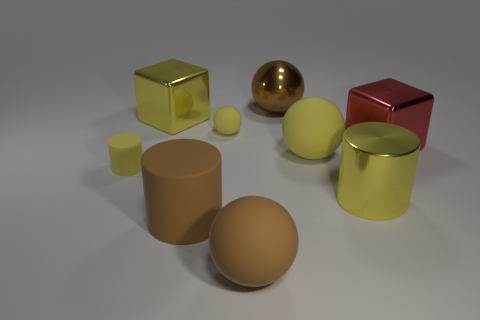Subtract all yellow cylinders. How many cylinders are left? 1 Subtract all yellow blocks. How many yellow cylinders are left? 2 Add 1 brown cylinders. How many objects exist? 10 Subtract all balls. How many objects are left? 5 Subtract all gray cylinders. Subtract all purple blocks. How many cylinders are left? 3 Subtract all big blue metal spheres. Subtract all big metal objects. How many objects are left? 5 Add 5 yellow matte balls. How many yellow matte balls are left? 7 Add 7 green cubes. How many green cubes exist? 7 Subtract 1 brown balls. How many objects are left? 8 